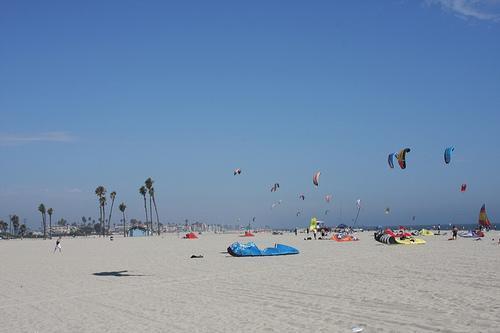How many groups of clouds are visible?
Give a very brief answer. 3. How many umbrellas are there?
Give a very brief answer. 0. 